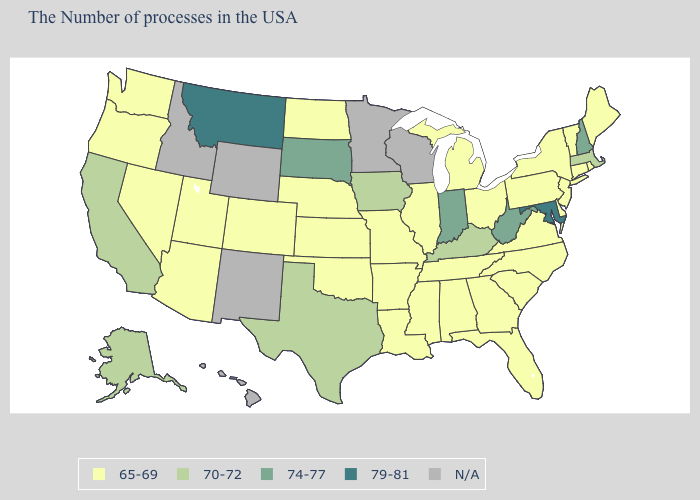Name the states that have a value in the range 79-81?
Write a very short answer. Maryland, Montana. What is the highest value in the USA?
Give a very brief answer. 79-81. What is the value of Colorado?
Give a very brief answer. 65-69. How many symbols are there in the legend?
Answer briefly. 5. What is the lowest value in the West?
Keep it brief. 65-69. Among the states that border Kentucky , does Illinois have the lowest value?
Answer briefly. Yes. Which states have the lowest value in the Northeast?
Write a very short answer. Maine, Rhode Island, Vermont, Connecticut, New York, New Jersey, Pennsylvania. Name the states that have a value in the range 79-81?
Answer briefly. Maryland, Montana. Does Iowa have the lowest value in the USA?
Answer briefly. No. What is the lowest value in states that border Oklahoma?
Keep it brief. 65-69. What is the highest value in states that border Oklahoma?
Quick response, please. 70-72. Name the states that have a value in the range 65-69?
Give a very brief answer. Maine, Rhode Island, Vermont, Connecticut, New York, New Jersey, Delaware, Pennsylvania, Virginia, North Carolina, South Carolina, Ohio, Florida, Georgia, Michigan, Alabama, Tennessee, Illinois, Mississippi, Louisiana, Missouri, Arkansas, Kansas, Nebraska, Oklahoma, North Dakota, Colorado, Utah, Arizona, Nevada, Washington, Oregon. What is the value of Vermont?
Write a very short answer. 65-69. Among the states that border Mississippi , which have the highest value?
Quick response, please. Alabama, Tennessee, Louisiana, Arkansas. 